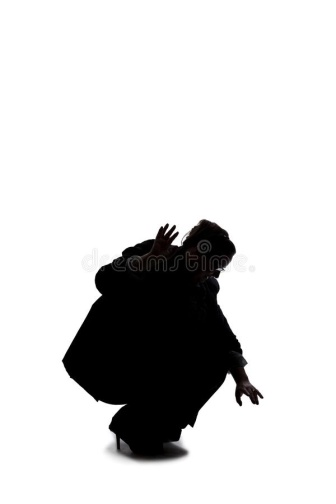What could the stark white background symbolize in this image? The stark white background in the image could symbolize a multitude of things depending on the context one imagines. It might represent a blank slate, suggesting that the person is starting fresh, unburdened by any preconceived notions or past experiences. Alternatively, the white expanse could signify isolation or emptiness, highlighting the individual's solitude and the dramatic nature of their pose. It could also serve to strip away external distractions, focusing the viewer's attention solely on the figure and their intense posture. In a more abstract sense, the white backdrop might symbolize purity or a transcendental realm, where the figure is caught in a moment that transcends ordinary reality, inviting the viewer to ponder deeper existential questions. 